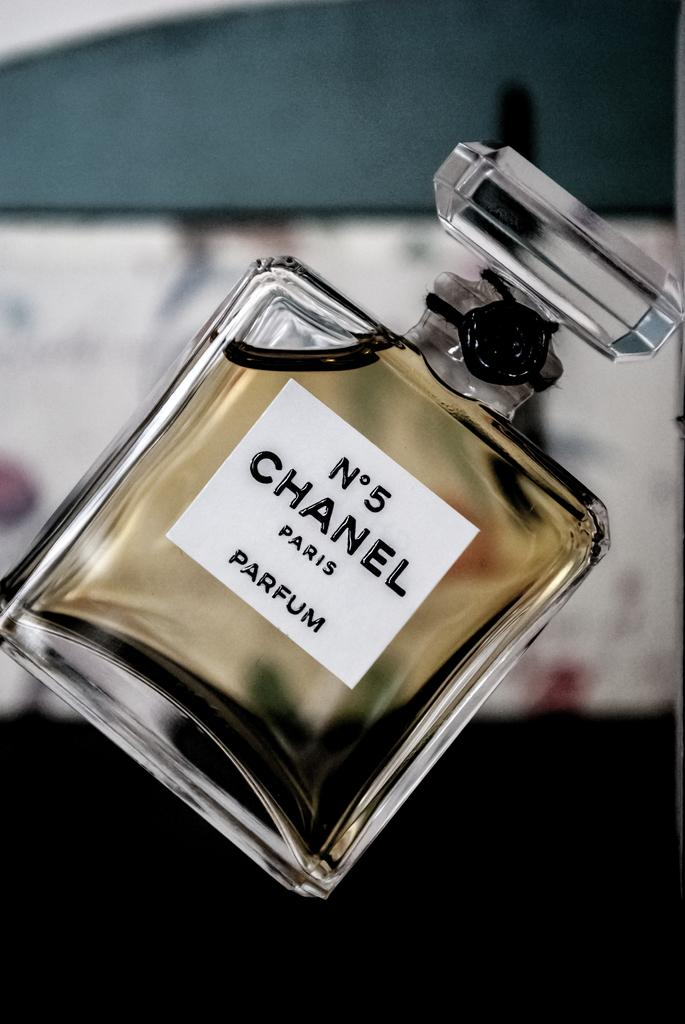Provide a one-sentence caption for the provided image. A full bottle of Chanel No 5 perfume is show at an angle. 